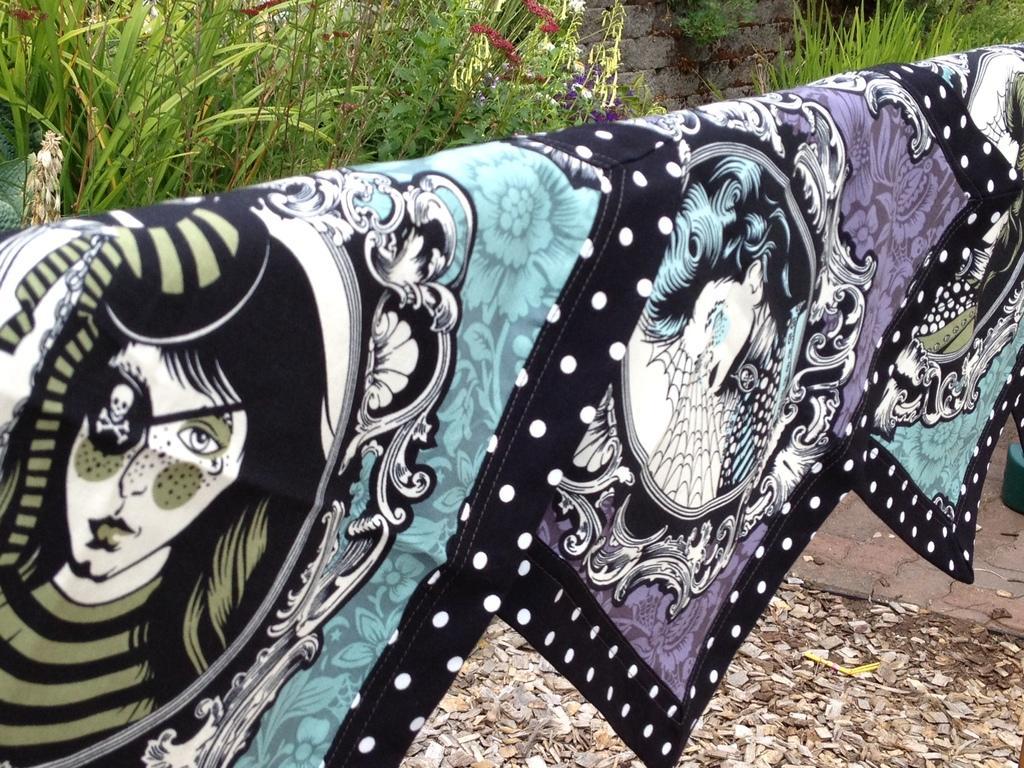How would you summarize this image in a sentence or two? In the center of the image we can see the clothes. In the background of the image we can see the plants, flowers, wall. At the bottom of the image we can see the saw dust and floor. 